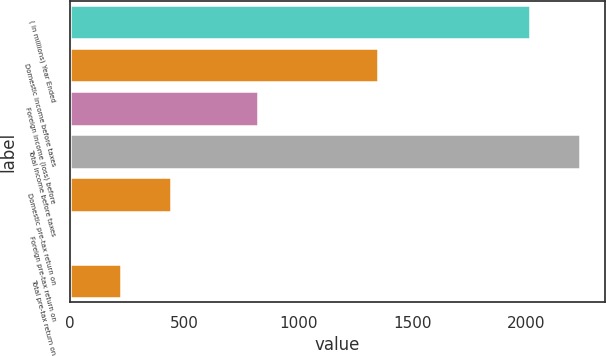Convert chart to OTSL. <chart><loc_0><loc_0><loc_500><loc_500><bar_chart><fcel>( in millions) Year Ended<fcel>Domestic income before taxes<fcel>Foreign income (loss) before<fcel>Total income before taxes<fcel>Domestic pre-tax return on<fcel>Foreign pre-tax return on<fcel>Total pre-tax return on<nl><fcel>2017<fcel>1347.8<fcel>825.5<fcel>2233.41<fcel>442.02<fcel>9.2<fcel>225.61<nl></chart> 